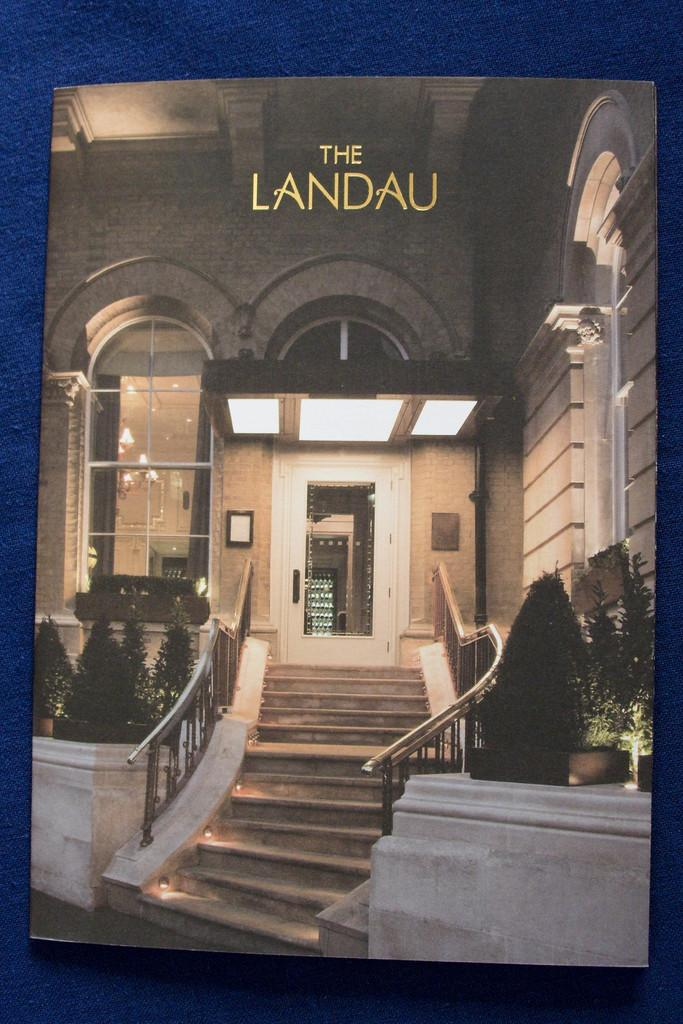<image>
Share a concise interpretation of the image provided. Stairs lead to the entry door of The Landau. 